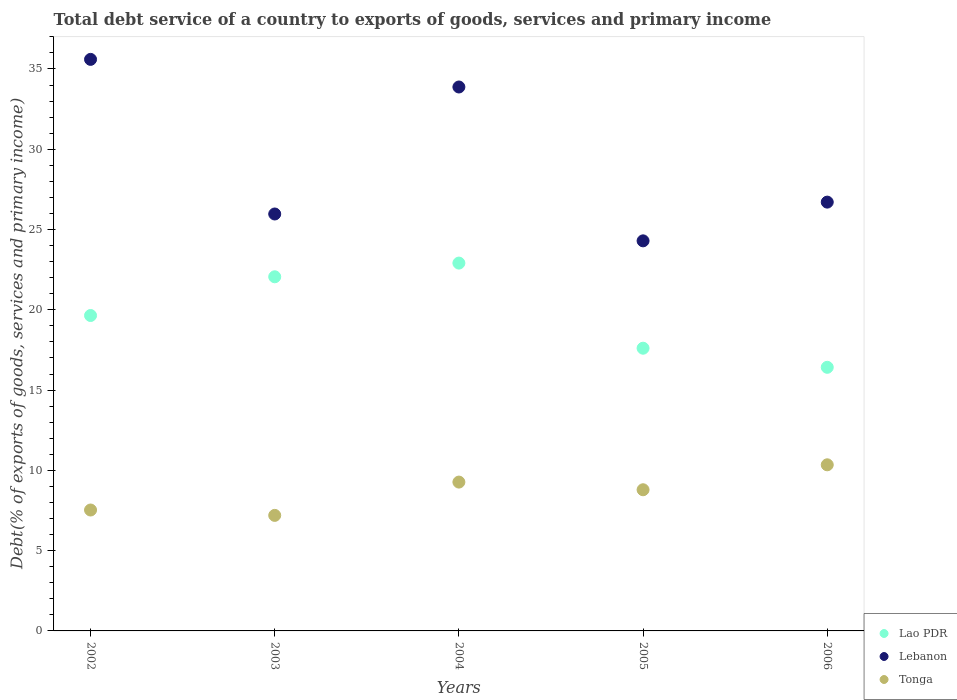How many different coloured dotlines are there?
Your answer should be compact. 3. Is the number of dotlines equal to the number of legend labels?
Your answer should be compact. Yes. What is the total debt service in Lao PDR in 2004?
Provide a succinct answer. 22.91. Across all years, what is the maximum total debt service in Lao PDR?
Your answer should be compact. 22.91. Across all years, what is the minimum total debt service in Lao PDR?
Offer a very short reply. 16.42. What is the total total debt service in Lao PDR in the graph?
Provide a short and direct response. 98.64. What is the difference between the total debt service in Lao PDR in 2002 and that in 2006?
Your response must be concise. 3.23. What is the difference between the total debt service in Lao PDR in 2003 and the total debt service in Tonga in 2005?
Offer a very short reply. 13.26. What is the average total debt service in Lao PDR per year?
Provide a short and direct response. 19.73. In the year 2003, what is the difference between the total debt service in Lebanon and total debt service in Tonga?
Your response must be concise. 18.77. What is the ratio of the total debt service in Lebanon in 2003 to that in 2005?
Your response must be concise. 1.07. What is the difference between the highest and the second highest total debt service in Lao PDR?
Your response must be concise. 0.85. What is the difference between the highest and the lowest total debt service in Tonga?
Keep it short and to the point. 3.15. How many dotlines are there?
Your response must be concise. 3. How many years are there in the graph?
Provide a short and direct response. 5. Are the values on the major ticks of Y-axis written in scientific E-notation?
Your answer should be very brief. No. Does the graph contain grids?
Make the answer very short. No. Where does the legend appear in the graph?
Provide a succinct answer. Bottom right. How many legend labels are there?
Keep it short and to the point. 3. How are the legend labels stacked?
Give a very brief answer. Vertical. What is the title of the graph?
Give a very brief answer. Total debt service of a country to exports of goods, services and primary income. What is the label or title of the X-axis?
Provide a succinct answer. Years. What is the label or title of the Y-axis?
Your answer should be very brief. Debt(% of exports of goods, services and primary income). What is the Debt(% of exports of goods, services and primary income) of Lao PDR in 2002?
Make the answer very short. 19.65. What is the Debt(% of exports of goods, services and primary income) in Lebanon in 2002?
Provide a short and direct response. 35.6. What is the Debt(% of exports of goods, services and primary income) in Tonga in 2002?
Offer a very short reply. 7.53. What is the Debt(% of exports of goods, services and primary income) in Lao PDR in 2003?
Offer a very short reply. 22.06. What is the Debt(% of exports of goods, services and primary income) of Lebanon in 2003?
Ensure brevity in your answer.  25.97. What is the Debt(% of exports of goods, services and primary income) of Tonga in 2003?
Your response must be concise. 7.2. What is the Debt(% of exports of goods, services and primary income) in Lao PDR in 2004?
Your response must be concise. 22.91. What is the Debt(% of exports of goods, services and primary income) of Lebanon in 2004?
Provide a succinct answer. 33.88. What is the Debt(% of exports of goods, services and primary income) of Tonga in 2004?
Provide a succinct answer. 9.27. What is the Debt(% of exports of goods, services and primary income) of Lao PDR in 2005?
Give a very brief answer. 17.61. What is the Debt(% of exports of goods, services and primary income) of Lebanon in 2005?
Make the answer very short. 24.3. What is the Debt(% of exports of goods, services and primary income) in Tonga in 2005?
Offer a very short reply. 8.79. What is the Debt(% of exports of goods, services and primary income) of Lao PDR in 2006?
Your answer should be compact. 16.42. What is the Debt(% of exports of goods, services and primary income) in Lebanon in 2006?
Provide a short and direct response. 26.71. What is the Debt(% of exports of goods, services and primary income) in Tonga in 2006?
Offer a terse response. 10.35. Across all years, what is the maximum Debt(% of exports of goods, services and primary income) of Lao PDR?
Your answer should be compact. 22.91. Across all years, what is the maximum Debt(% of exports of goods, services and primary income) of Lebanon?
Keep it short and to the point. 35.6. Across all years, what is the maximum Debt(% of exports of goods, services and primary income) of Tonga?
Offer a terse response. 10.35. Across all years, what is the minimum Debt(% of exports of goods, services and primary income) in Lao PDR?
Your answer should be very brief. 16.42. Across all years, what is the minimum Debt(% of exports of goods, services and primary income) in Lebanon?
Provide a short and direct response. 24.3. Across all years, what is the minimum Debt(% of exports of goods, services and primary income) of Tonga?
Offer a very short reply. 7.2. What is the total Debt(% of exports of goods, services and primary income) of Lao PDR in the graph?
Provide a short and direct response. 98.64. What is the total Debt(% of exports of goods, services and primary income) of Lebanon in the graph?
Make the answer very short. 146.45. What is the total Debt(% of exports of goods, services and primary income) of Tonga in the graph?
Provide a succinct answer. 43.14. What is the difference between the Debt(% of exports of goods, services and primary income) of Lao PDR in 2002 and that in 2003?
Give a very brief answer. -2.41. What is the difference between the Debt(% of exports of goods, services and primary income) in Lebanon in 2002 and that in 2003?
Provide a short and direct response. 9.63. What is the difference between the Debt(% of exports of goods, services and primary income) in Tonga in 2002 and that in 2003?
Ensure brevity in your answer.  0.33. What is the difference between the Debt(% of exports of goods, services and primary income) of Lao PDR in 2002 and that in 2004?
Provide a succinct answer. -3.27. What is the difference between the Debt(% of exports of goods, services and primary income) in Lebanon in 2002 and that in 2004?
Provide a succinct answer. 1.72. What is the difference between the Debt(% of exports of goods, services and primary income) of Tonga in 2002 and that in 2004?
Provide a succinct answer. -1.74. What is the difference between the Debt(% of exports of goods, services and primary income) in Lao PDR in 2002 and that in 2005?
Offer a very short reply. 2.04. What is the difference between the Debt(% of exports of goods, services and primary income) in Lebanon in 2002 and that in 2005?
Your response must be concise. 11.3. What is the difference between the Debt(% of exports of goods, services and primary income) of Tonga in 2002 and that in 2005?
Keep it short and to the point. -1.26. What is the difference between the Debt(% of exports of goods, services and primary income) of Lao PDR in 2002 and that in 2006?
Your answer should be compact. 3.23. What is the difference between the Debt(% of exports of goods, services and primary income) of Lebanon in 2002 and that in 2006?
Offer a very short reply. 8.89. What is the difference between the Debt(% of exports of goods, services and primary income) of Tonga in 2002 and that in 2006?
Provide a succinct answer. -2.82. What is the difference between the Debt(% of exports of goods, services and primary income) in Lao PDR in 2003 and that in 2004?
Provide a succinct answer. -0.85. What is the difference between the Debt(% of exports of goods, services and primary income) of Lebanon in 2003 and that in 2004?
Ensure brevity in your answer.  -7.91. What is the difference between the Debt(% of exports of goods, services and primary income) of Tonga in 2003 and that in 2004?
Your answer should be compact. -2.07. What is the difference between the Debt(% of exports of goods, services and primary income) in Lao PDR in 2003 and that in 2005?
Provide a succinct answer. 4.45. What is the difference between the Debt(% of exports of goods, services and primary income) of Lebanon in 2003 and that in 2005?
Keep it short and to the point. 1.67. What is the difference between the Debt(% of exports of goods, services and primary income) of Tonga in 2003 and that in 2005?
Your answer should be very brief. -1.6. What is the difference between the Debt(% of exports of goods, services and primary income) in Lao PDR in 2003 and that in 2006?
Your answer should be very brief. 5.64. What is the difference between the Debt(% of exports of goods, services and primary income) in Lebanon in 2003 and that in 2006?
Keep it short and to the point. -0.74. What is the difference between the Debt(% of exports of goods, services and primary income) of Tonga in 2003 and that in 2006?
Offer a terse response. -3.15. What is the difference between the Debt(% of exports of goods, services and primary income) of Lao PDR in 2004 and that in 2005?
Your response must be concise. 5.3. What is the difference between the Debt(% of exports of goods, services and primary income) of Lebanon in 2004 and that in 2005?
Provide a short and direct response. 9.58. What is the difference between the Debt(% of exports of goods, services and primary income) in Tonga in 2004 and that in 2005?
Keep it short and to the point. 0.48. What is the difference between the Debt(% of exports of goods, services and primary income) of Lao PDR in 2004 and that in 2006?
Offer a terse response. 6.49. What is the difference between the Debt(% of exports of goods, services and primary income) of Lebanon in 2004 and that in 2006?
Give a very brief answer. 7.17. What is the difference between the Debt(% of exports of goods, services and primary income) of Tonga in 2004 and that in 2006?
Keep it short and to the point. -1.08. What is the difference between the Debt(% of exports of goods, services and primary income) in Lao PDR in 2005 and that in 2006?
Your response must be concise. 1.19. What is the difference between the Debt(% of exports of goods, services and primary income) of Lebanon in 2005 and that in 2006?
Make the answer very short. -2.41. What is the difference between the Debt(% of exports of goods, services and primary income) of Tonga in 2005 and that in 2006?
Offer a very short reply. -1.55. What is the difference between the Debt(% of exports of goods, services and primary income) in Lao PDR in 2002 and the Debt(% of exports of goods, services and primary income) in Lebanon in 2003?
Keep it short and to the point. -6.32. What is the difference between the Debt(% of exports of goods, services and primary income) in Lao PDR in 2002 and the Debt(% of exports of goods, services and primary income) in Tonga in 2003?
Your answer should be very brief. 12.45. What is the difference between the Debt(% of exports of goods, services and primary income) of Lebanon in 2002 and the Debt(% of exports of goods, services and primary income) of Tonga in 2003?
Your response must be concise. 28.4. What is the difference between the Debt(% of exports of goods, services and primary income) of Lao PDR in 2002 and the Debt(% of exports of goods, services and primary income) of Lebanon in 2004?
Your answer should be very brief. -14.23. What is the difference between the Debt(% of exports of goods, services and primary income) of Lao PDR in 2002 and the Debt(% of exports of goods, services and primary income) of Tonga in 2004?
Provide a succinct answer. 10.38. What is the difference between the Debt(% of exports of goods, services and primary income) in Lebanon in 2002 and the Debt(% of exports of goods, services and primary income) in Tonga in 2004?
Your answer should be very brief. 26.33. What is the difference between the Debt(% of exports of goods, services and primary income) of Lao PDR in 2002 and the Debt(% of exports of goods, services and primary income) of Lebanon in 2005?
Ensure brevity in your answer.  -4.65. What is the difference between the Debt(% of exports of goods, services and primary income) in Lao PDR in 2002 and the Debt(% of exports of goods, services and primary income) in Tonga in 2005?
Give a very brief answer. 10.85. What is the difference between the Debt(% of exports of goods, services and primary income) in Lebanon in 2002 and the Debt(% of exports of goods, services and primary income) in Tonga in 2005?
Ensure brevity in your answer.  26.81. What is the difference between the Debt(% of exports of goods, services and primary income) in Lao PDR in 2002 and the Debt(% of exports of goods, services and primary income) in Lebanon in 2006?
Provide a succinct answer. -7.06. What is the difference between the Debt(% of exports of goods, services and primary income) in Lao PDR in 2002 and the Debt(% of exports of goods, services and primary income) in Tonga in 2006?
Your answer should be very brief. 9.3. What is the difference between the Debt(% of exports of goods, services and primary income) of Lebanon in 2002 and the Debt(% of exports of goods, services and primary income) of Tonga in 2006?
Offer a very short reply. 25.25. What is the difference between the Debt(% of exports of goods, services and primary income) of Lao PDR in 2003 and the Debt(% of exports of goods, services and primary income) of Lebanon in 2004?
Your answer should be very brief. -11.82. What is the difference between the Debt(% of exports of goods, services and primary income) in Lao PDR in 2003 and the Debt(% of exports of goods, services and primary income) in Tonga in 2004?
Keep it short and to the point. 12.79. What is the difference between the Debt(% of exports of goods, services and primary income) of Lebanon in 2003 and the Debt(% of exports of goods, services and primary income) of Tonga in 2004?
Offer a terse response. 16.7. What is the difference between the Debt(% of exports of goods, services and primary income) in Lao PDR in 2003 and the Debt(% of exports of goods, services and primary income) in Lebanon in 2005?
Provide a succinct answer. -2.24. What is the difference between the Debt(% of exports of goods, services and primary income) of Lao PDR in 2003 and the Debt(% of exports of goods, services and primary income) of Tonga in 2005?
Ensure brevity in your answer.  13.26. What is the difference between the Debt(% of exports of goods, services and primary income) of Lebanon in 2003 and the Debt(% of exports of goods, services and primary income) of Tonga in 2005?
Provide a succinct answer. 17.18. What is the difference between the Debt(% of exports of goods, services and primary income) in Lao PDR in 2003 and the Debt(% of exports of goods, services and primary income) in Lebanon in 2006?
Your answer should be very brief. -4.65. What is the difference between the Debt(% of exports of goods, services and primary income) of Lao PDR in 2003 and the Debt(% of exports of goods, services and primary income) of Tonga in 2006?
Your response must be concise. 11.71. What is the difference between the Debt(% of exports of goods, services and primary income) of Lebanon in 2003 and the Debt(% of exports of goods, services and primary income) of Tonga in 2006?
Provide a succinct answer. 15.62. What is the difference between the Debt(% of exports of goods, services and primary income) of Lao PDR in 2004 and the Debt(% of exports of goods, services and primary income) of Lebanon in 2005?
Ensure brevity in your answer.  -1.39. What is the difference between the Debt(% of exports of goods, services and primary income) of Lao PDR in 2004 and the Debt(% of exports of goods, services and primary income) of Tonga in 2005?
Ensure brevity in your answer.  14.12. What is the difference between the Debt(% of exports of goods, services and primary income) of Lebanon in 2004 and the Debt(% of exports of goods, services and primary income) of Tonga in 2005?
Your response must be concise. 25.09. What is the difference between the Debt(% of exports of goods, services and primary income) of Lao PDR in 2004 and the Debt(% of exports of goods, services and primary income) of Lebanon in 2006?
Offer a very short reply. -3.8. What is the difference between the Debt(% of exports of goods, services and primary income) in Lao PDR in 2004 and the Debt(% of exports of goods, services and primary income) in Tonga in 2006?
Keep it short and to the point. 12.56. What is the difference between the Debt(% of exports of goods, services and primary income) in Lebanon in 2004 and the Debt(% of exports of goods, services and primary income) in Tonga in 2006?
Give a very brief answer. 23.53. What is the difference between the Debt(% of exports of goods, services and primary income) in Lao PDR in 2005 and the Debt(% of exports of goods, services and primary income) in Lebanon in 2006?
Provide a short and direct response. -9.1. What is the difference between the Debt(% of exports of goods, services and primary income) in Lao PDR in 2005 and the Debt(% of exports of goods, services and primary income) in Tonga in 2006?
Give a very brief answer. 7.26. What is the difference between the Debt(% of exports of goods, services and primary income) of Lebanon in 2005 and the Debt(% of exports of goods, services and primary income) of Tonga in 2006?
Offer a very short reply. 13.95. What is the average Debt(% of exports of goods, services and primary income) of Lao PDR per year?
Your answer should be compact. 19.73. What is the average Debt(% of exports of goods, services and primary income) of Lebanon per year?
Provide a succinct answer. 29.29. What is the average Debt(% of exports of goods, services and primary income) in Tonga per year?
Your answer should be compact. 8.63. In the year 2002, what is the difference between the Debt(% of exports of goods, services and primary income) of Lao PDR and Debt(% of exports of goods, services and primary income) of Lebanon?
Provide a short and direct response. -15.95. In the year 2002, what is the difference between the Debt(% of exports of goods, services and primary income) in Lao PDR and Debt(% of exports of goods, services and primary income) in Tonga?
Your answer should be compact. 12.11. In the year 2002, what is the difference between the Debt(% of exports of goods, services and primary income) of Lebanon and Debt(% of exports of goods, services and primary income) of Tonga?
Keep it short and to the point. 28.07. In the year 2003, what is the difference between the Debt(% of exports of goods, services and primary income) in Lao PDR and Debt(% of exports of goods, services and primary income) in Lebanon?
Ensure brevity in your answer.  -3.91. In the year 2003, what is the difference between the Debt(% of exports of goods, services and primary income) in Lao PDR and Debt(% of exports of goods, services and primary income) in Tonga?
Keep it short and to the point. 14.86. In the year 2003, what is the difference between the Debt(% of exports of goods, services and primary income) in Lebanon and Debt(% of exports of goods, services and primary income) in Tonga?
Ensure brevity in your answer.  18.77. In the year 2004, what is the difference between the Debt(% of exports of goods, services and primary income) of Lao PDR and Debt(% of exports of goods, services and primary income) of Lebanon?
Give a very brief answer. -10.97. In the year 2004, what is the difference between the Debt(% of exports of goods, services and primary income) in Lao PDR and Debt(% of exports of goods, services and primary income) in Tonga?
Keep it short and to the point. 13.64. In the year 2004, what is the difference between the Debt(% of exports of goods, services and primary income) of Lebanon and Debt(% of exports of goods, services and primary income) of Tonga?
Your answer should be compact. 24.61. In the year 2005, what is the difference between the Debt(% of exports of goods, services and primary income) in Lao PDR and Debt(% of exports of goods, services and primary income) in Lebanon?
Your answer should be very brief. -6.69. In the year 2005, what is the difference between the Debt(% of exports of goods, services and primary income) of Lao PDR and Debt(% of exports of goods, services and primary income) of Tonga?
Make the answer very short. 8.82. In the year 2005, what is the difference between the Debt(% of exports of goods, services and primary income) in Lebanon and Debt(% of exports of goods, services and primary income) in Tonga?
Offer a terse response. 15.5. In the year 2006, what is the difference between the Debt(% of exports of goods, services and primary income) in Lao PDR and Debt(% of exports of goods, services and primary income) in Lebanon?
Keep it short and to the point. -10.29. In the year 2006, what is the difference between the Debt(% of exports of goods, services and primary income) of Lao PDR and Debt(% of exports of goods, services and primary income) of Tonga?
Your answer should be compact. 6.07. In the year 2006, what is the difference between the Debt(% of exports of goods, services and primary income) in Lebanon and Debt(% of exports of goods, services and primary income) in Tonga?
Keep it short and to the point. 16.36. What is the ratio of the Debt(% of exports of goods, services and primary income) of Lao PDR in 2002 to that in 2003?
Your response must be concise. 0.89. What is the ratio of the Debt(% of exports of goods, services and primary income) of Lebanon in 2002 to that in 2003?
Provide a succinct answer. 1.37. What is the ratio of the Debt(% of exports of goods, services and primary income) in Tonga in 2002 to that in 2003?
Provide a succinct answer. 1.05. What is the ratio of the Debt(% of exports of goods, services and primary income) of Lao PDR in 2002 to that in 2004?
Your answer should be compact. 0.86. What is the ratio of the Debt(% of exports of goods, services and primary income) of Lebanon in 2002 to that in 2004?
Offer a terse response. 1.05. What is the ratio of the Debt(% of exports of goods, services and primary income) of Tonga in 2002 to that in 2004?
Your answer should be very brief. 0.81. What is the ratio of the Debt(% of exports of goods, services and primary income) in Lao PDR in 2002 to that in 2005?
Offer a very short reply. 1.12. What is the ratio of the Debt(% of exports of goods, services and primary income) of Lebanon in 2002 to that in 2005?
Your answer should be compact. 1.47. What is the ratio of the Debt(% of exports of goods, services and primary income) of Tonga in 2002 to that in 2005?
Offer a terse response. 0.86. What is the ratio of the Debt(% of exports of goods, services and primary income) in Lao PDR in 2002 to that in 2006?
Keep it short and to the point. 1.2. What is the ratio of the Debt(% of exports of goods, services and primary income) in Lebanon in 2002 to that in 2006?
Offer a terse response. 1.33. What is the ratio of the Debt(% of exports of goods, services and primary income) in Tonga in 2002 to that in 2006?
Offer a terse response. 0.73. What is the ratio of the Debt(% of exports of goods, services and primary income) in Lao PDR in 2003 to that in 2004?
Give a very brief answer. 0.96. What is the ratio of the Debt(% of exports of goods, services and primary income) in Lebanon in 2003 to that in 2004?
Your answer should be very brief. 0.77. What is the ratio of the Debt(% of exports of goods, services and primary income) in Tonga in 2003 to that in 2004?
Offer a very short reply. 0.78. What is the ratio of the Debt(% of exports of goods, services and primary income) in Lao PDR in 2003 to that in 2005?
Offer a terse response. 1.25. What is the ratio of the Debt(% of exports of goods, services and primary income) in Lebanon in 2003 to that in 2005?
Your response must be concise. 1.07. What is the ratio of the Debt(% of exports of goods, services and primary income) in Tonga in 2003 to that in 2005?
Ensure brevity in your answer.  0.82. What is the ratio of the Debt(% of exports of goods, services and primary income) in Lao PDR in 2003 to that in 2006?
Provide a short and direct response. 1.34. What is the ratio of the Debt(% of exports of goods, services and primary income) in Lebanon in 2003 to that in 2006?
Your response must be concise. 0.97. What is the ratio of the Debt(% of exports of goods, services and primary income) in Tonga in 2003 to that in 2006?
Give a very brief answer. 0.7. What is the ratio of the Debt(% of exports of goods, services and primary income) in Lao PDR in 2004 to that in 2005?
Your answer should be compact. 1.3. What is the ratio of the Debt(% of exports of goods, services and primary income) in Lebanon in 2004 to that in 2005?
Provide a succinct answer. 1.39. What is the ratio of the Debt(% of exports of goods, services and primary income) of Tonga in 2004 to that in 2005?
Ensure brevity in your answer.  1.05. What is the ratio of the Debt(% of exports of goods, services and primary income) in Lao PDR in 2004 to that in 2006?
Your response must be concise. 1.4. What is the ratio of the Debt(% of exports of goods, services and primary income) in Lebanon in 2004 to that in 2006?
Provide a succinct answer. 1.27. What is the ratio of the Debt(% of exports of goods, services and primary income) in Tonga in 2004 to that in 2006?
Provide a short and direct response. 0.9. What is the ratio of the Debt(% of exports of goods, services and primary income) in Lao PDR in 2005 to that in 2006?
Offer a terse response. 1.07. What is the ratio of the Debt(% of exports of goods, services and primary income) in Lebanon in 2005 to that in 2006?
Provide a succinct answer. 0.91. What is the ratio of the Debt(% of exports of goods, services and primary income) in Tonga in 2005 to that in 2006?
Keep it short and to the point. 0.85. What is the difference between the highest and the second highest Debt(% of exports of goods, services and primary income) of Lao PDR?
Your response must be concise. 0.85. What is the difference between the highest and the second highest Debt(% of exports of goods, services and primary income) in Lebanon?
Offer a terse response. 1.72. What is the difference between the highest and the second highest Debt(% of exports of goods, services and primary income) in Tonga?
Your answer should be compact. 1.08. What is the difference between the highest and the lowest Debt(% of exports of goods, services and primary income) of Lao PDR?
Your response must be concise. 6.49. What is the difference between the highest and the lowest Debt(% of exports of goods, services and primary income) in Lebanon?
Make the answer very short. 11.3. What is the difference between the highest and the lowest Debt(% of exports of goods, services and primary income) in Tonga?
Give a very brief answer. 3.15. 